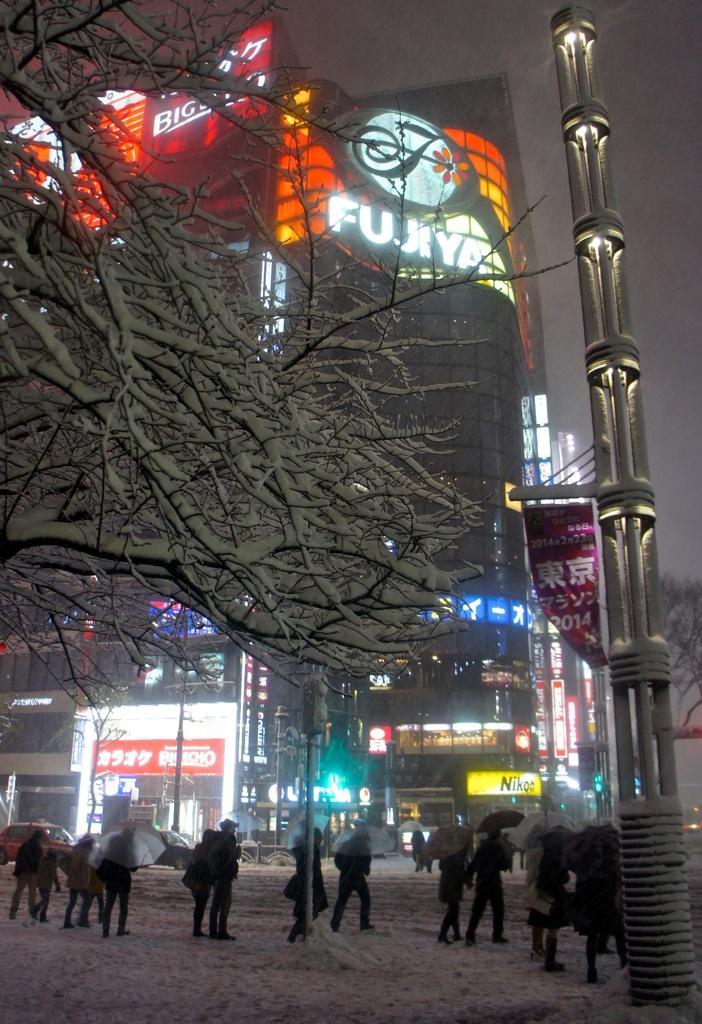Please provide a concise description of this image. In this image we can see persons standing on the road by holding umbrellas, snow, trees, tower, buildings and sky. 